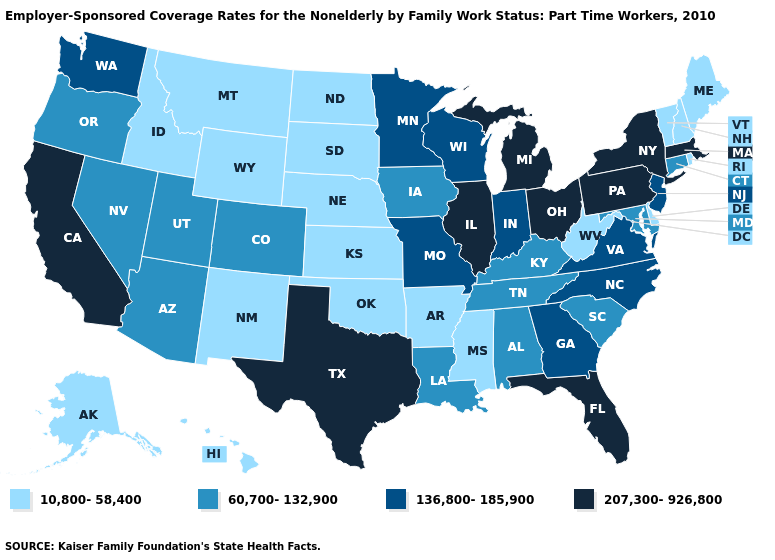Name the states that have a value in the range 10,800-58,400?
Be succinct. Alaska, Arkansas, Delaware, Hawaii, Idaho, Kansas, Maine, Mississippi, Montana, Nebraska, New Hampshire, New Mexico, North Dakota, Oklahoma, Rhode Island, South Dakota, Vermont, West Virginia, Wyoming. Which states have the lowest value in the South?
Keep it brief. Arkansas, Delaware, Mississippi, Oklahoma, West Virginia. Name the states that have a value in the range 60,700-132,900?
Quick response, please. Alabama, Arizona, Colorado, Connecticut, Iowa, Kentucky, Louisiana, Maryland, Nevada, Oregon, South Carolina, Tennessee, Utah. Among the states that border Washington , does Oregon have the highest value?
Write a very short answer. Yes. Which states have the lowest value in the USA?
Short answer required. Alaska, Arkansas, Delaware, Hawaii, Idaho, Kansas, Maine, Mississippi, Montana, Nebraska, New Hampshire, New Mexico, North Dakota, Oklahoma, Rhode Island, South Dakota, Vermont, West Virginia, Wyoming. Among the states that border Illinois , does Missouri have the lowest value?
Keep it brief. No. Name the states that have a value in the range 207,300-926,800?
Give a very brief answer. California, Florida, Illinois, Massachusetts, Michigan, New York, Ohio, Pennsylvania, Texas. Name the states that have a value in the range 60,700-132,900?
Answer briefly. Alabama, Arizona, Colorado, Connecticut, Iowa, Kentucky, Louisiana, Maryland, Nevada, Oregon, South Carolina, Tennessee, Utah. Name the states that have a value in the range 207,300-926,800?
Be succinct. California, Florida, Illinois, Massachusetts, Michigan, New York, Ohio, Pennsylvania, Texas. Does California have the highest value in the West?
Quick response, please. Yes. Among the states that border New Mexico , which have the highest value?
Concise answer only. Texas. What is the value of North Carolina?
Give a very brief answer. 136,800-185,900. Among the states that border Missouri , does Arkansas have the lowest value?
Keep it brief. Yes. Name the states that have a value in the range 10,800-58,400?
Give a very brief answer. Alaska, Arkansas, Delaware, Hawaii, Idaho, Kansas, Maine, Mississippi, Montana, Nebraska, New Hampshire, New Mexico, North Dakota, Oklahoma, Rhode Island, South Dakota, Vermont, West Virginia, Wyoming. Which states have the lowest value in the USA?
Quick response, please. Alaska, Arkansas, Delaware, Hawaii, Idaho, Kansas, Maine, Mississippi, Montana, Nebraska, New Hampshire, New Mexico, North Dakota, Oklahoma, Rhode Island, South Dakota, Vermont, West Virginia, Wyoming. 